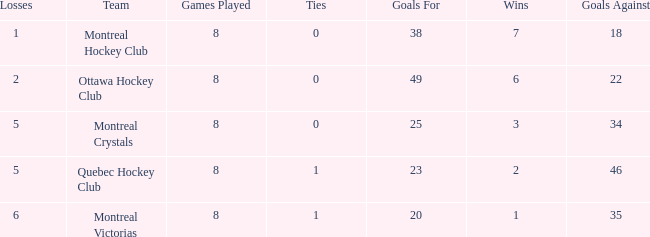What is the highest goals against when the wins is less than 1? None. 